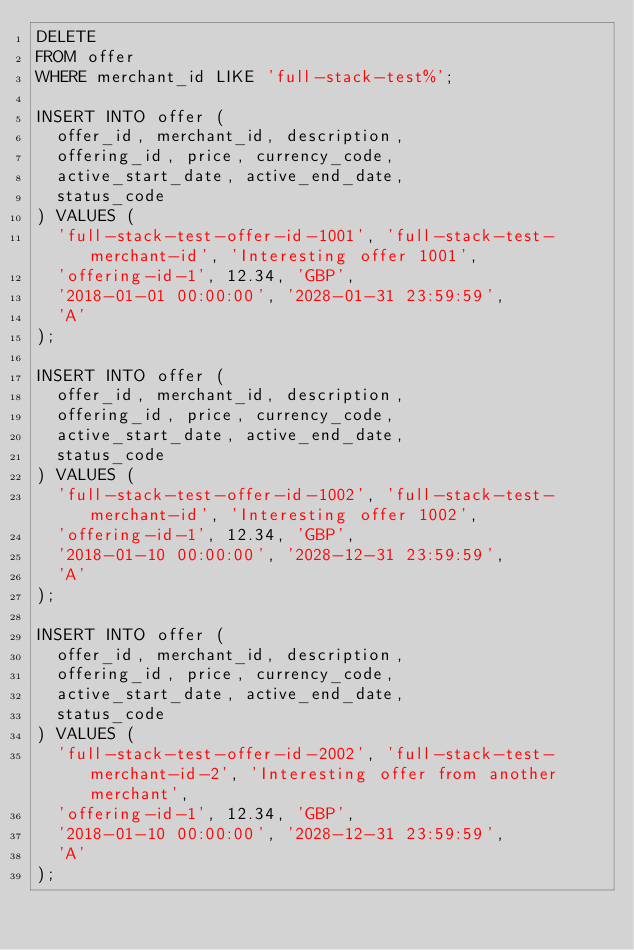<code> <loc_0><loc_0><loc_500><loc_500><_SQL_>DELETE
FROM offer
WHERE merchant_id LIKE 'full-stack-test%';

INSERT INTO offer (
  offer_id, merchant_id, description,
  offering_id, price, currency_code,
  active_start_date, active_end_date,
  status_code
) VALUES (
  'full-stack-test-offer-id-1001', 'full-stack-test-merchant-id', 'Interesting offer 1001',
  'offering-id-1', 12.34, 'GBP',
  '2018-01-01 00:00:00', '2028-01-31 23:59:59',
  'A'
);

INSERT INTO offer (
  offer_id, merchant_id, description,
  offering_id, price, currency_code,
  active_start_date, active_end_date,
  status_code
) VALUES (
  'full-stack-test-offer-id-1002', 'full-stack-test-merchant-id', 'Interesting offer 1002',
  'offering-id-1', 12.34, 'GBP',
  '2018-01-10 00:00:00', '2028-12-31 23:59:59',
  'A'
);

INSERT INTO offer (
  offer_id, merchant_id, description,
  offering_id, price, currency_code,
  active_start_date, active_end_date,
  status_code
) VALUES (
  'full-stack-test-offer-id-2002', 'full-stack-test-merchant-id-2', 'Interesting offer from another merchant',
  'offering-id-1', 12.34, 'GBP',
  '2018-01-10 00:00:00', '2028-12-31 23:59:59',
  'A'
);
</code> 